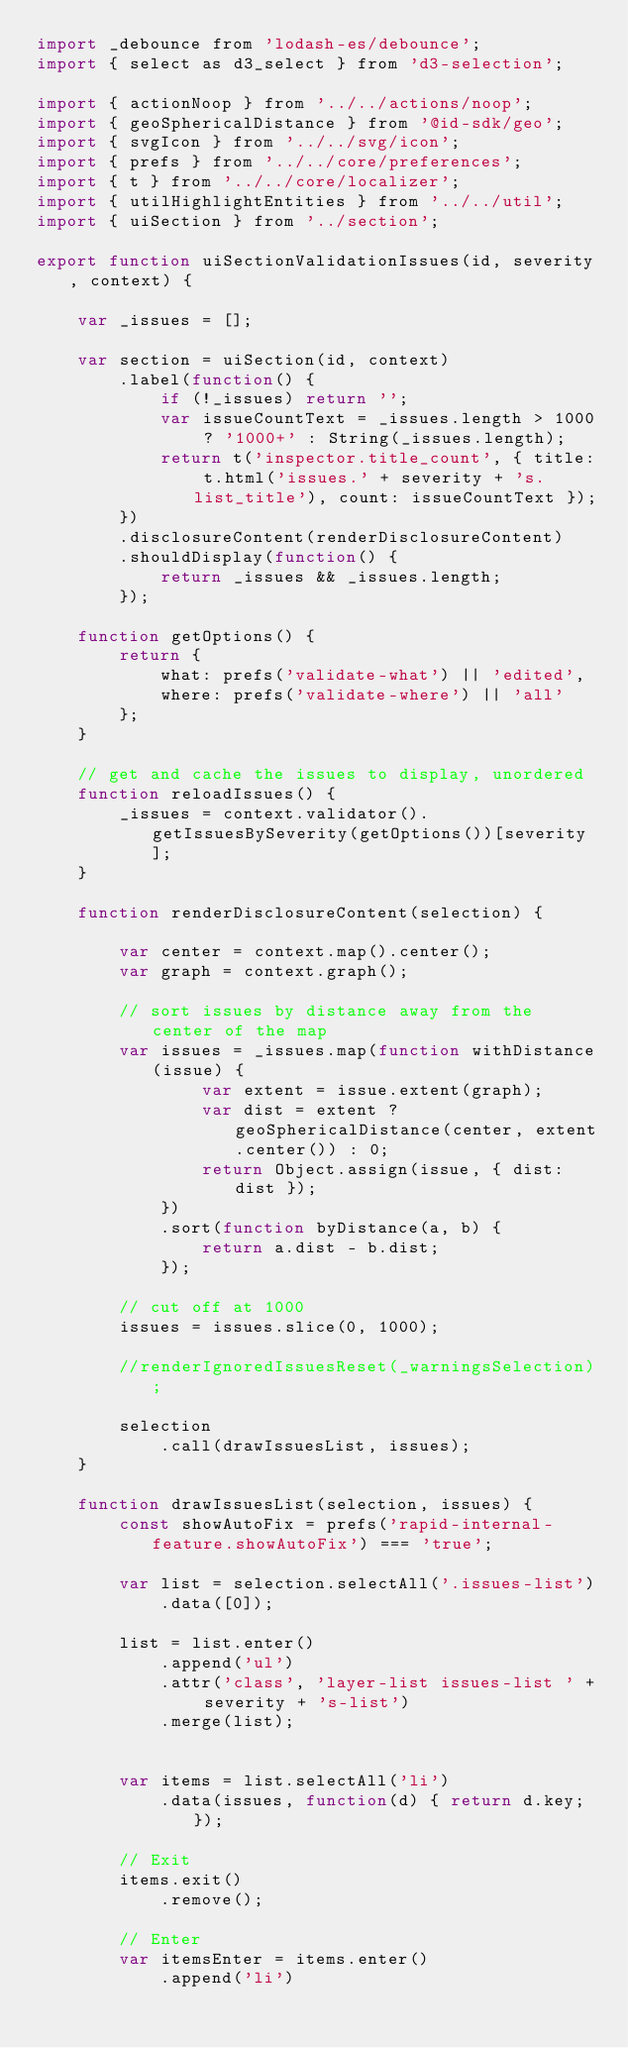<code> <loc_0><loc_0><loc_500><loc_500><_JavaScript_>import _debounce from 'lodash-es/debounce';
import { select as d3_select } from 'd3-selection';

import { actionNoop } from '../../actions/noop';
import { geoSphericalDistance } from '@id-sdk/geo';
import { svgIcon } from '../../svg/icon';
import { prefs } from '../../core/preferences';
import { t } from '../../core/localizer';
import { utilHighlightEntities } from '../../util';
import { uiSection } from '../section';

export function uiSectionValidationIssues(id, severity, context) {

    var _issues = [];

    var section = uiSection(id, context)
        .label(function() {
            if (!_issues) return '';
            var issueCountText = _issues.length > 1000 ? '1000+' : String(_issues.length);
            return t('inspector.title_count', { title: t.html('issues.' + severity + 's.list_title'), count: issueCountText });
        })
        .disclosureContent(renderDisclosureContent)
        .shouldDisplay(function() {
            return _issues && _issues.length;
        });

    function getOptions() {
        return {
            what: prefs('validate-what') || 'edited',
            where: prefs('validate-where') || 'all'
        };
    }

    // get and cache the issues to display, unordered
    function reloadIssues() {
        _issues = context.validator().getIssuesBySeverity(getOptions())[severity];
    }

    function renderDisclosureContent(selection) {

        var center = context.map().center();
        var graph = context.graph();

        // sort issues by distance away from the center of the map
        var issues = _issues.map(function withDistance(issue) {
                var extent = issue.extent(graph);
                var dist = extent ? geoSphericalDistance(center, extent.center()) : 0;
                return Object.assign(issue, { dist: dist });
            })
            .sort(function byDistance(a, b) {
                return a.dist - b.dist;
            });

        // cut off at 1000
        issues = issues.slice(0, 1000);

        //renderIgnoredIssuesReset(_warningsSelection);

        selection
            .call(drawIssuesList, issues);
    }

    function drawIssuesList(selection, issues) {
        const showAutoFix = prefs('rapid-internal-feature.showAutoFix') === 'true';

        var list = selection.selectAll('.issues-list')
            .data([0]);

        list = list.enter()
            .append('ul')
            .attr('class', 'layer-list issues-list ' + severity + 's-list')
            .merge(list);


        var items = list.selectAll('li')
            .data(issues, function(d) { return d.key; });

        // Exit
        items.exit()
            .remove();

        // Enter
        var itemsEnter = items.enter()
            .append('li')</code> 